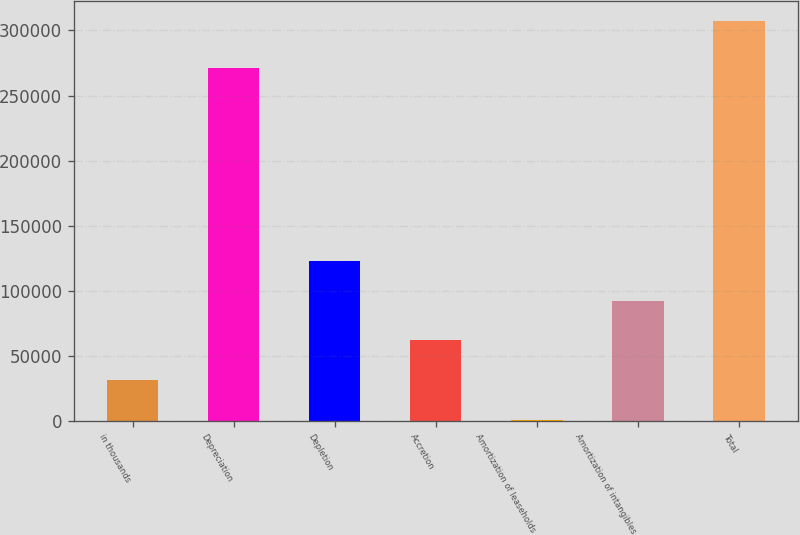Convert chart to OTSL. <chart><loc_0><loc_0><loc_500><loc_500><bar_chart><fcel>in thousands<fcel>Depreciation<fcel>Depletion<fcel>Accretion<fcel>Amortization of leaseholds<fcel>Amortization of intangibles<fcel>Total<nl><fcel>31145.5<fcel>271180<fcel>123133<fcel>61808<fcel>483<fcel>92470.5<fcel>307108<nl></chart> 